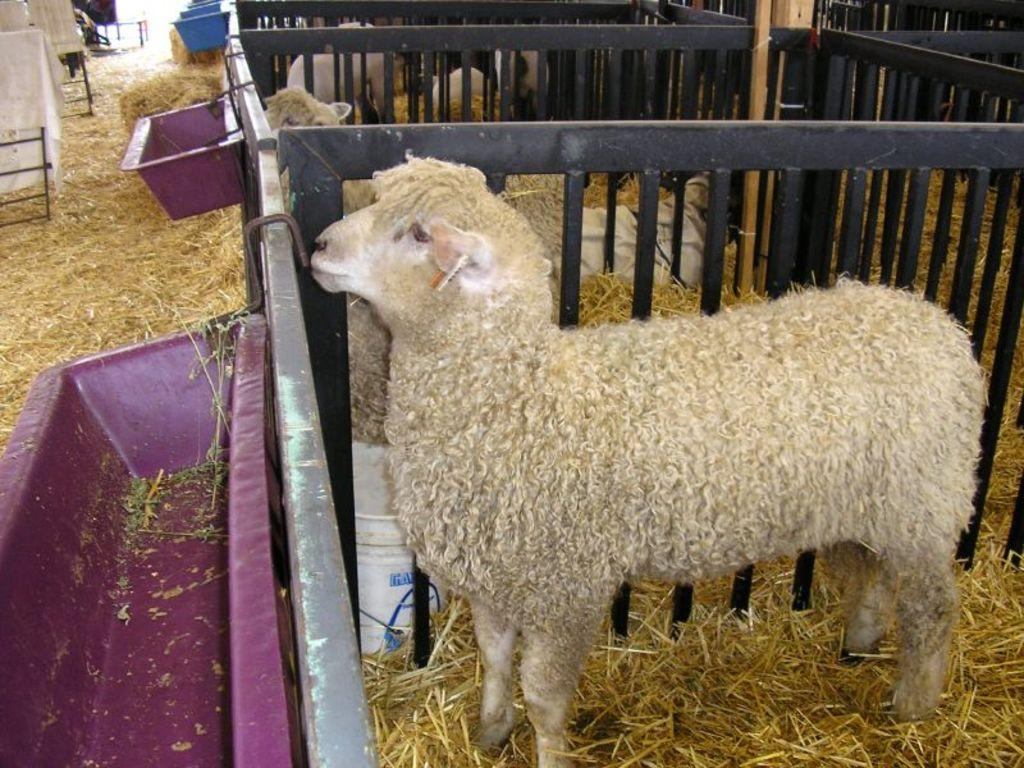What animals can be seen behind the railings in the image? There are sheeps behind the railings in the image. What type of vegetation is present at the bottom of the image? There is grass at the bottom of the image. What objects are located at the bottom of the image? There are buckets at the bottom of the image. Where else can buckets be found in the image? Buckets can also be found on the railing on the left side of the image. What color is the leaf on the sheeps' wool in the image? There is no leaf present in the image, and the sheep's wool is not mentioned to have any specific color. What is the chance of the sheeps jumping over the railing in the image? The image does not provide any information about the sheeps' behavior or the likelihood of them jumping over the railing. 